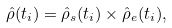Convert formula to latex. <formula><loc_0><loc_0><loc_500><loc_500>\hat { \rho } ( t _ { i } ) = \hat { \rho } _ { s } ( t _ { i } ) \times \hat { \rho } _ { e } ( t _ { i } ) ,</formula> 